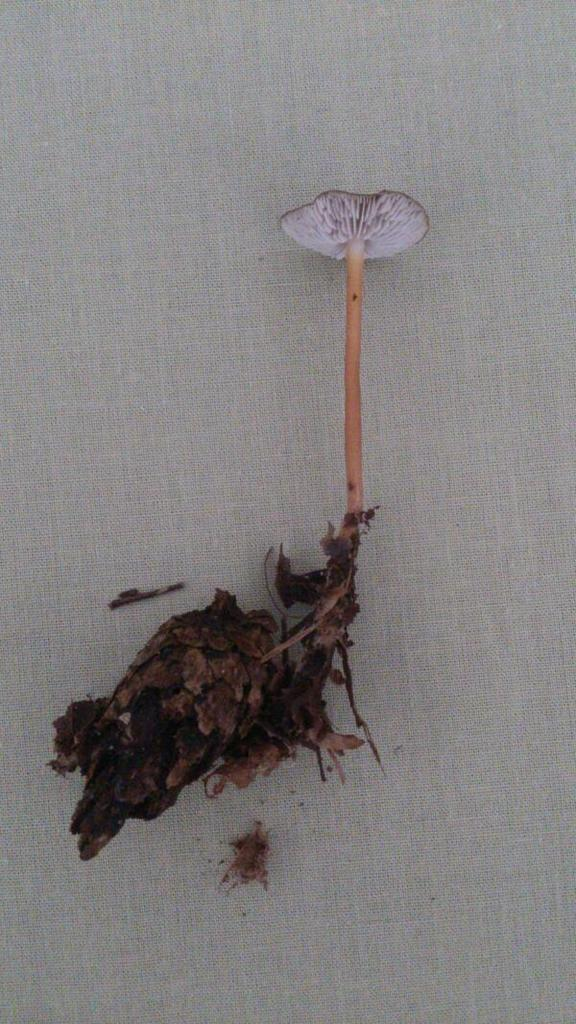What type of living organism is in the image? There is a plant with roots in the image. Where is the plant located? The plant is on a surface in the image. What color is the background of the image? The background of the image is cream in color. What type of liquid is being poured by the minister in the image? There is no minister or liquid present in the image; it features a plant with roots on a surface with a cream-colored background. 